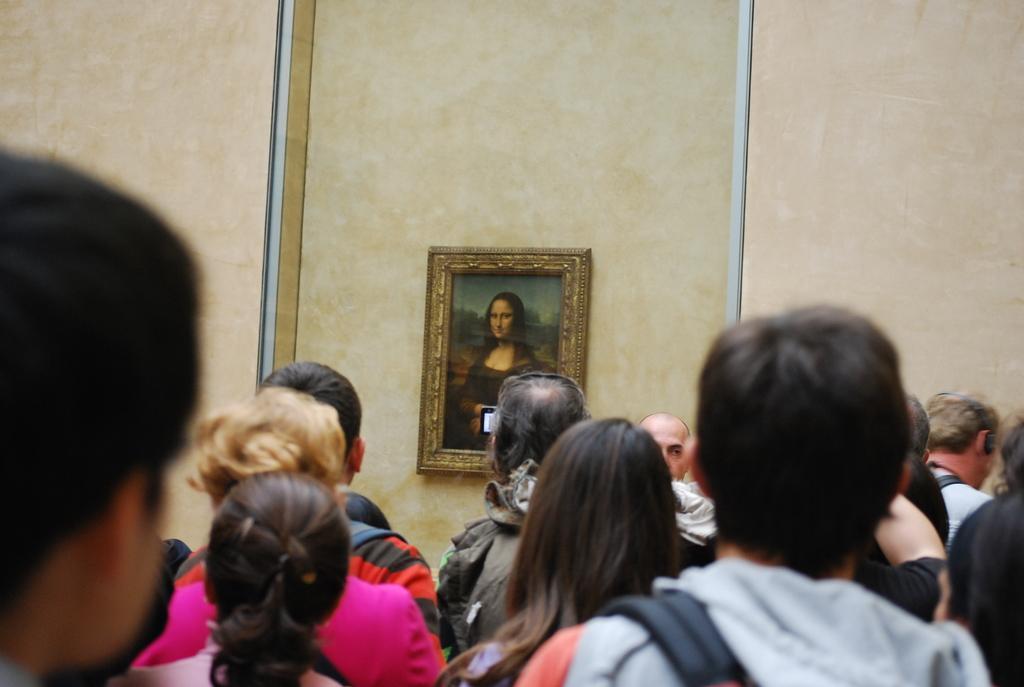Describe this image in one or two sentences. In the picture we can see some people are standing and looking to the wall with a photo frame and Monalisa painting on it. 